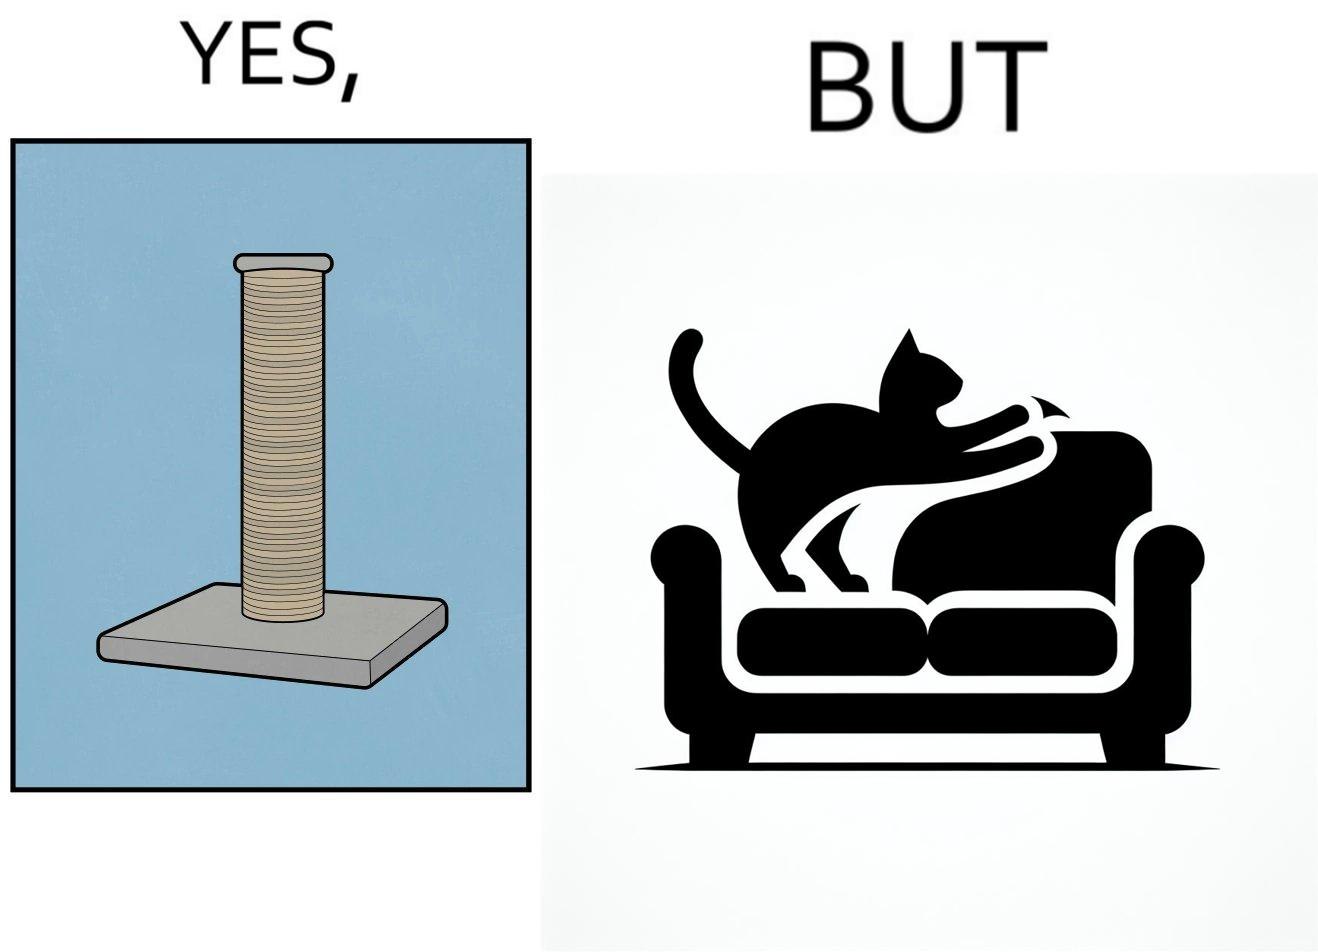Describe the content of this image. The image is ironic, because in the first image a toy, purposed for the cat to play with is shown but in the second image the cat is comfortably enjoying  to play on the sides of sofa 